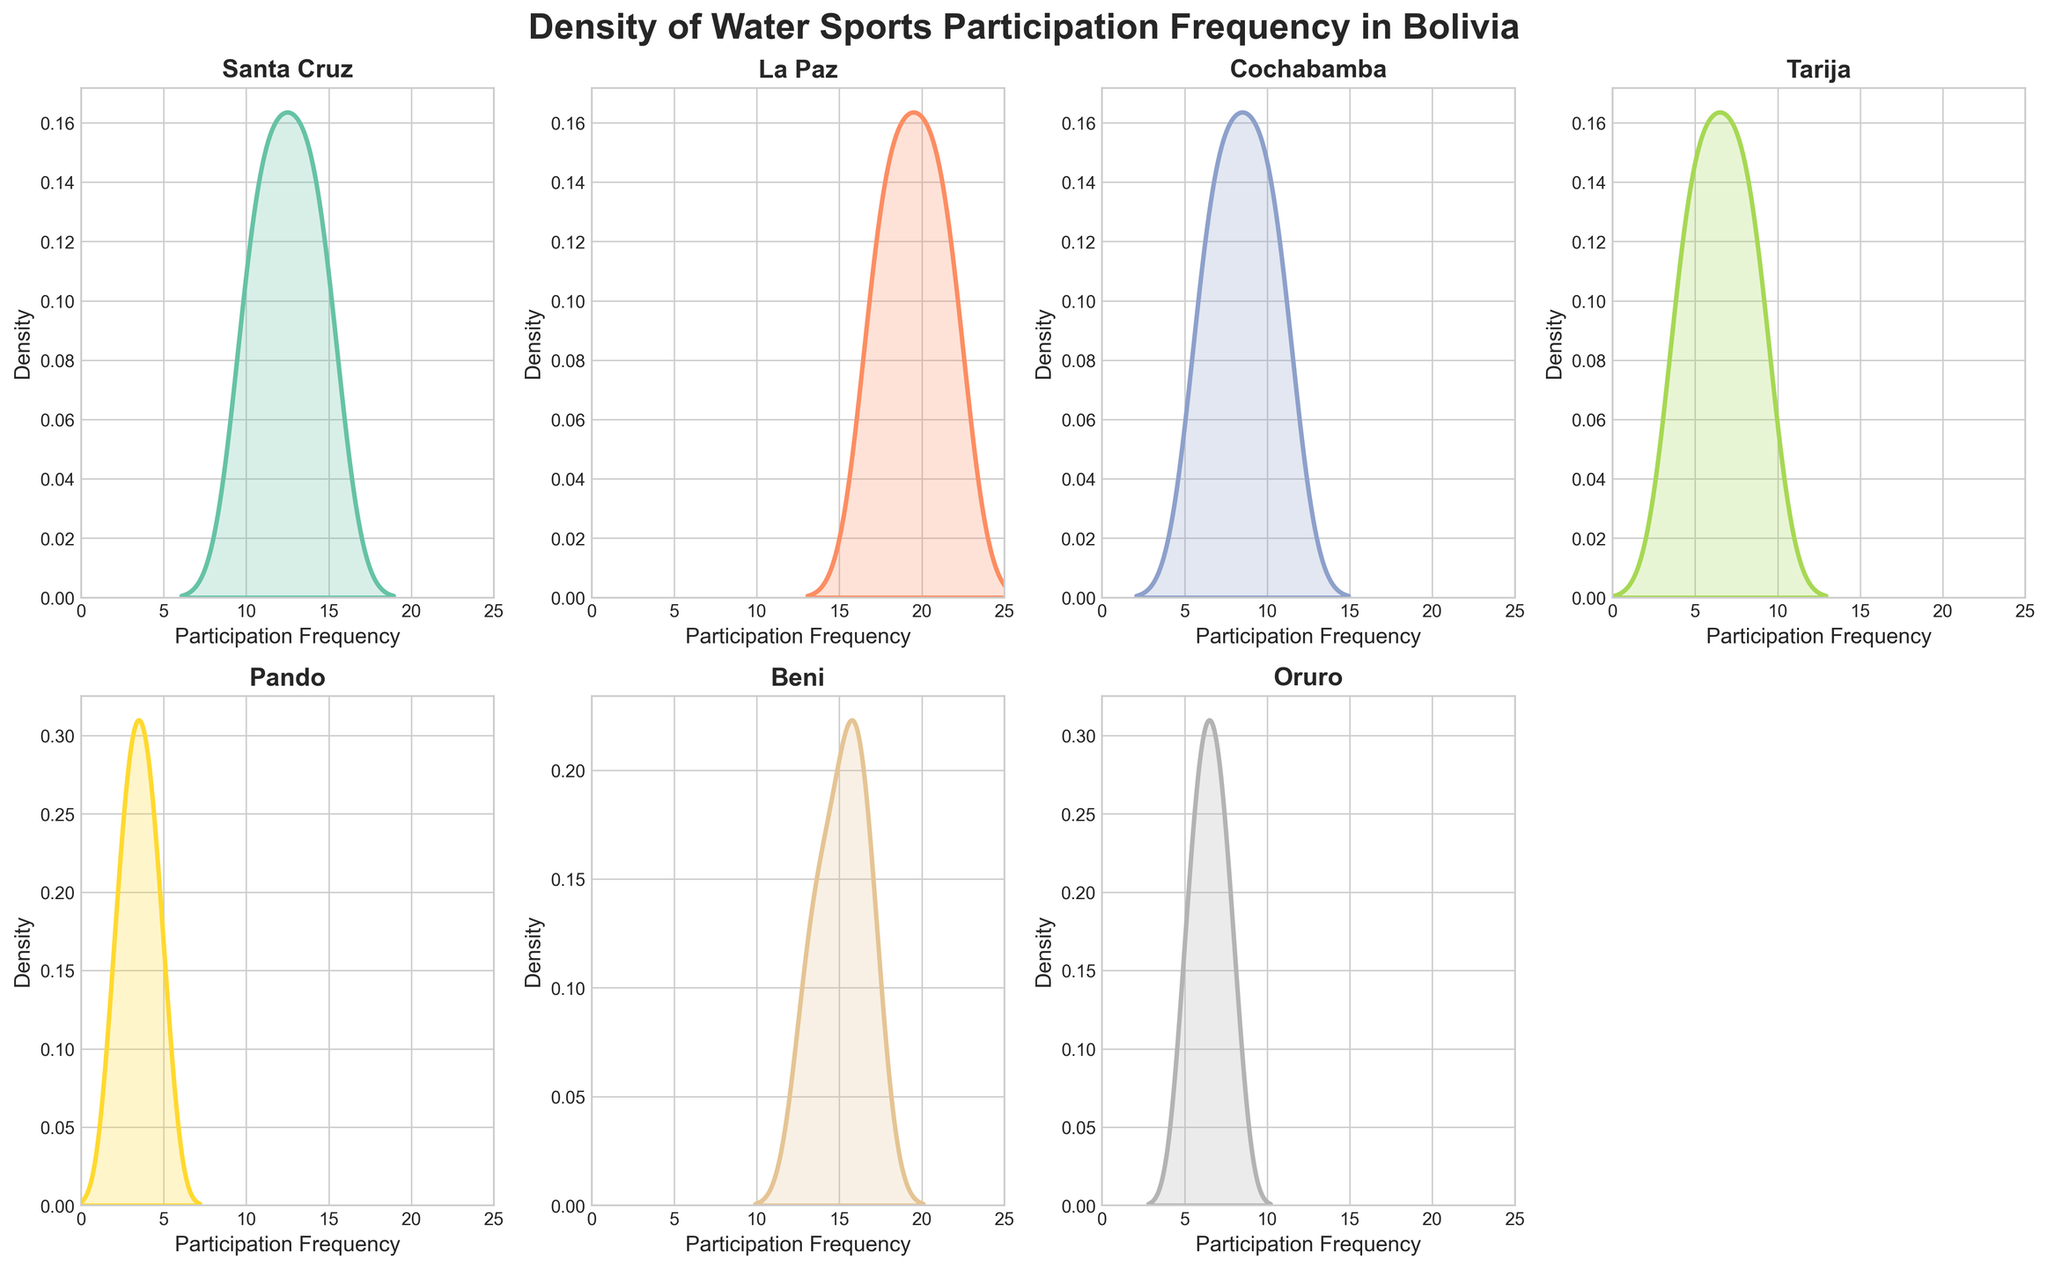What is the title of the plot? The title is located at the top of the plot and it reads "Density of Water Sports Participation Frequency in Bolivia".
Answer: Density of Water Sports Participation Frequency in Bolivia Which regions are included in the figure? Each subplot title indicates a different region. The regions include Santa Cruz, La Paz, Cochabamba, Tarija, Pando, Beni, and Oruro.
Answer: Santa Cruz, La Paz, Cochabamba, Tarija, Pando, Beni, Oruro Which region shows the highest participation frequency in water sports? By looking at the peaks of the density plots for each region, La Paz has the highest density peak around the 20-22 participation frequency range.
Answer: La Paz Which regions have a participation frequency distribution with a peak around 10? By observing the density plots, Santa Cruz and Cochabamba show peaks around 10 participation frequency.
Answer: Santa Cruz, Cochabamba Is there any region with a participation frequency distribution stretching as low as 2? Observing the x-axes of the subplots, Pando's distribution extends as low as 2.
Answer: Pando Does Beni have a higher participation frequency compared to Tarija? The density peak of Beni is around 15-17, while Tarija's density peak is around 4-9, indicating higher participation in Beni.
Answer: Yes Which region has the most spread out participation frequencies? By comparing the spread of the density curves, La Paz has the most spread out distribution, ranging from around 17 to 22.
Answer: La Paz What's the approximate range of participation frequencies for Oruro? The density plot for Oruro spans from around 5 to 8 participation frequencies.
Answer: 5 to 8 Which regions show overlapping participation frequency ranges between 6-9? By identifying overlapping regions in the density curves, Cochabamba, Tarija, and Oruro all show participation frequencies between 6-9.
Answer: Cochabamba, Tarija, Oruro 